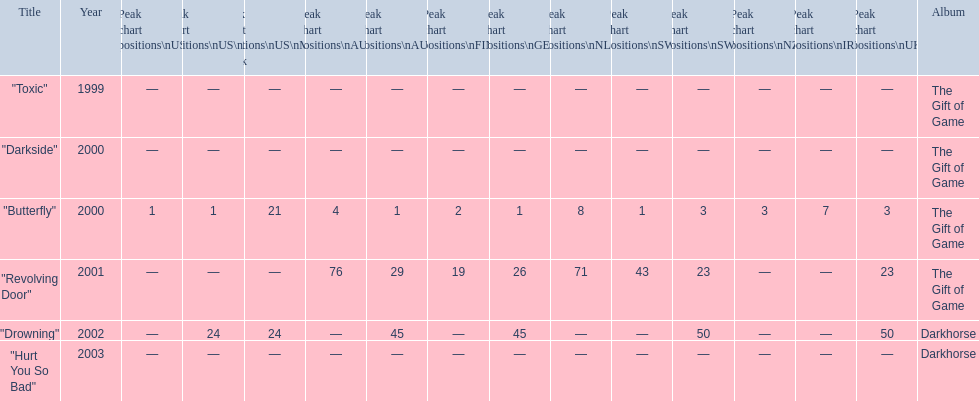How many singles have a ranking of 1 under ger? 1. 